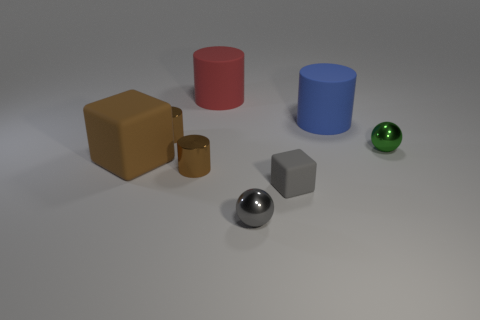What shape is the big brown matte thing left of the block right of the large red matte object?
Provide a short and direct response. Cube. Do the brown rubber object and the thing that is in front of the tiny rubber object have the same size?
Provide a short and direct response. No. There is a gray matte thing in front of the matte cylinder right of the cube that is to the right of the gray metallic sphere; what size is it?
Keep it short and to the point. Small. How many things are things that are in front of the big matte block or large green rubber cylinders?
Provide a short and direct response. 3. There is a large cylinder left of the tiny cube; what number of brown cylinders are to the left of it?
Provide a succinct answer. 2. Are there more big brown rubber blocks right of the small gray metal thing than big blocks?
Offer a very short reply. No. There is a matte object that is in front of the green thing and to the left of the small rubber object; how big is it?
Provide a short and direct response. Large. What shape is the object that is both to the left of the small gray cube and on the right side of the big red cylinder?
Your response must be concise. Sphere. There is a big rubber cylinder in front of the big matte cylinder behind the blue cylinder; are there any large red rubber cylinders that are behind it?
Your answer should be compact. Yes. What number of things are metallic objects on the left side of the large red cylinder or tiny metal things on the right side of the small gray metallic sphere?
Make the answer very short. 3. 